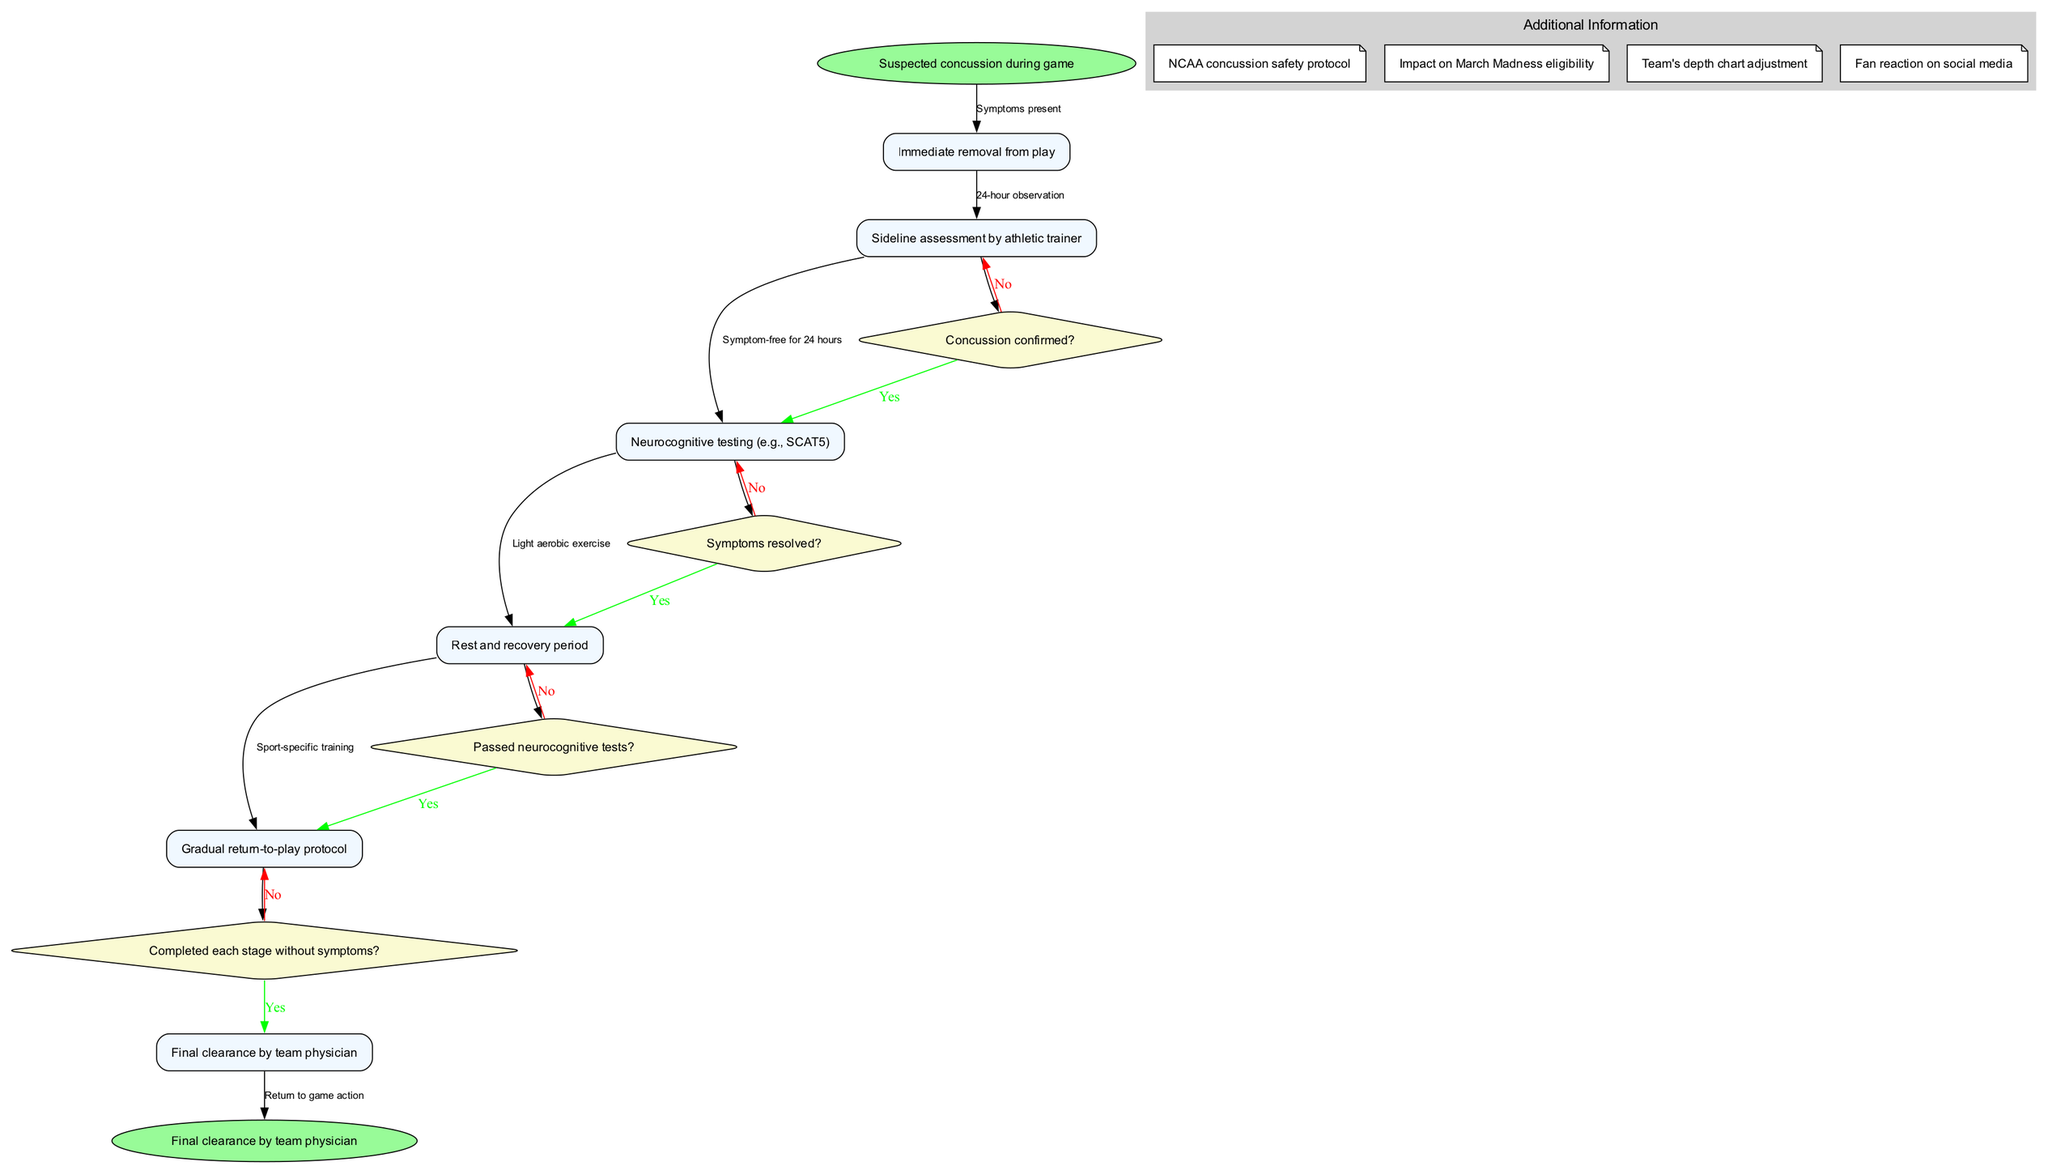What is the first step after a suspected concussion during a game? The diagram indicates that the immediate step following the suspicion of a concussion is "Immediate removal from play." This is the very first node after the start point in the clinical pathway.
Answer: Immediate removal from play How many main nodes are present in the pathway? By counting the nodes listed in the diagram, there are a total of six main nodes: "Immediate removal from play," "Sideline assessment by athletic trainer," "Neurocognitive testing (e.g., SCAT5)," "Rest and recovery period," "Gradual return-to-play protocol," and "Final clearance by team physician."
Answer: 6 What must be confirmed before proceeding to neurocognitive testing? According to the pathway, it is essential to confirm whether a concussion is confirmed before moving on to the neurocognitive testing step. This is outlined as a decision point, emphasizing the importance of confirming the condition.
Answer: Concussion confirmed? What is required following the "Rest and recovery period"? After the "Rest and recovery period," the next step explicitly shown in the diagram is "Gradual return-to-play protocol." This indicates a progression after the recovery phase.
Answer: Gradual return-to-play protocol What is the condition for moving from "Sideline assessment by athletic trainer" to "Neurocognitive testing"? The pathway specifies that a prerequisite for advancing from the sideline assessment to neurocognitive testing is confirming the presence of symptoms, verified through the decision point stating "Symptoms present?" This confirms cognitive function.
Answer: Symptoms present How many decision points are outlined in the diagram? The diagram highlights four distinct decision points: "Concussion confirmed?" "Symptoms resolved?" "Passed neurocognitive tests?" and "Completed each stage without symptoms?" Thus, there are four decision points overall in the clinical pathway.
Answer: 4 What is the final node in the pathway? The last node, which signifies the conclusion of the clinical pathway after all prior steps have been completed successfully, is "Return to game action." This indicates that the athlete is cleared to play.
Answer: Return to game action What happens if symptoms are not resolved after the rest period? If symptoms are not resolved, there is a transition back to the "Rest and recovery period" leading to further monitoring and treatment. This is depicted in the diagram as a necessary redirection, ensuring the athlete's safety.
Answer: Rest and recovery period What aspect of the protocol affects March Madness eligibility? The additional information present in the diagram specifies the "Impact on March Madness eligibility" as a critical consideration for players who may be sidelined due to concussions. This indicates that recovery processes could influence their ability to participate in this significant tournament.
Answer: Impact on March Madness eligibility 